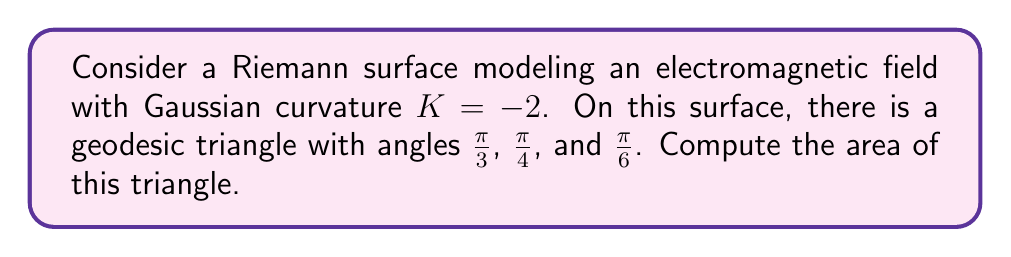Can you answer this question? To solve this problem, we'll use the Gauss-Bonnet theorem, which relates the geometry of a surface to its topology. For a geodesic triangle on a surface with Gaussian curvature $K$, the theorem states:

$$\int\int_R K dA + \int_{\partial R} k_g ds + \sum_{i=1}^3 \theta_i = 2\pi$$

Where:
- $R$ is the region enclosed by the triangle
- $\partial R$ is the boundary of the triangle
- $k_g$ is the geodesic curvature (which is zero for geodesics)
- $\theta_i$ are the interior angles of the triangle

Step 1: Simplify the equation
Since we're dealing with a geodesic triangle, $\int_{\partial R} k_g ds = 0$. The equation becomes:

$$\int\int_R K dA + \sum_{i=1}^3 \theta_i = 2\pi$$

Step 2: Substitute known values
$K = -2$ (given)
$\theta_1 = \frac{\pi}{3}, \theta_2 = \frac{\pi}{4}, \theta_3 = \frac{\pi}{6}$

$$-2A + \frac{\pi}{3} + \frac{\pi}{4} + \frac{\pi}{6} = 2\pi$$

Where $A$ is the area of the triangle.

Step 3: Simplify the angle sum
$$\frac{\pi}{3} + \frac{\pi}{4} + \frac{\pi}{6} = \frac{4\pi}{12} + \frac{3\pi}{12} + \frac{2\pi}{12} = \frac{9\pi}{12} = \frac{3\pi}{4}$$

Step 4: Solve for $A$
$$-2A + \frac{3\pi}{4} = 2\pi$$
$$-2A = 2\pi - \frac{3\pi}{4} = \frac{5\pi}{4}$$
$$A = -\frac{5\pi}{8}$$

Step 5: Take the absolute value
Since area is always positive, we take the absolute value of our result:

$$A = \left|\-\frac{5\pi}{8}\right| = \frac{5\pi}{8}$$
Answer: $\frac{5\pi}{8}$ 